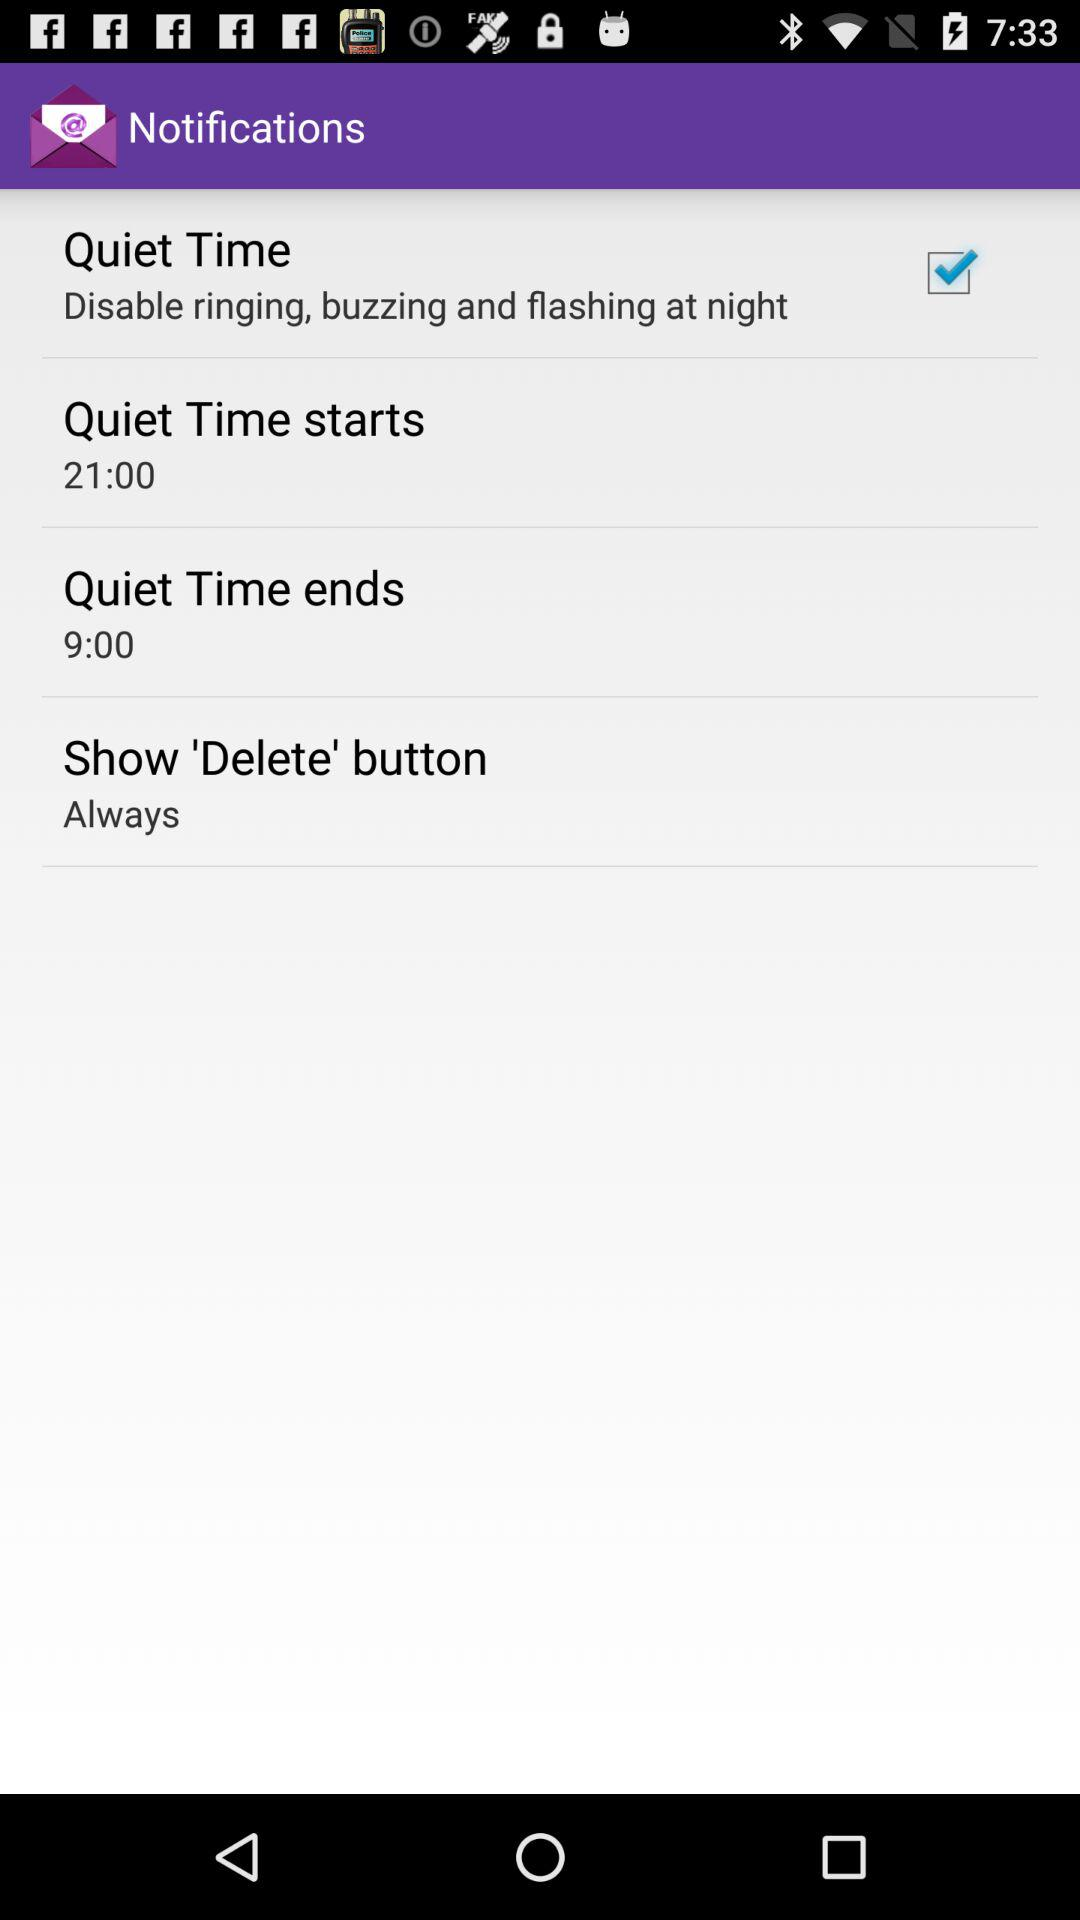What is the start time? The start time is 21:00. 